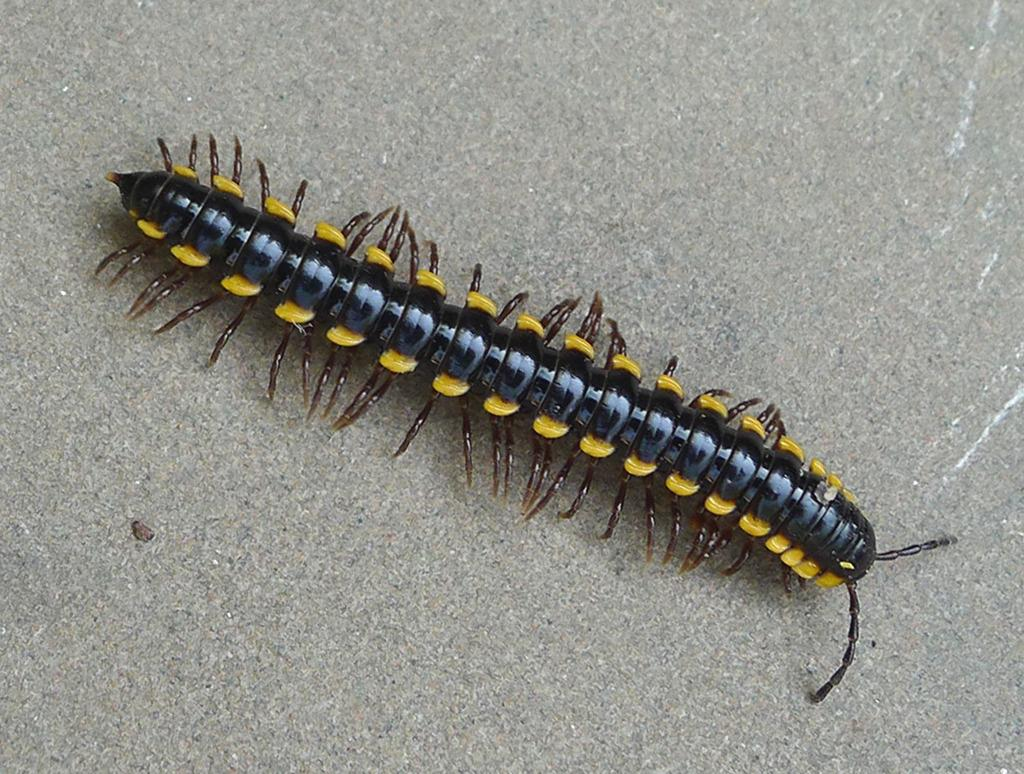What type of creatures are present in the image? There are millipedes in the image. What can be seen in the background of the image? There appears to be a wall in the background of the image. What type of art is being exchanged between the millipedes in the image? There is no art or exchange of any kind depicted in the image; it simply shows millipedes and a wall in the background. 